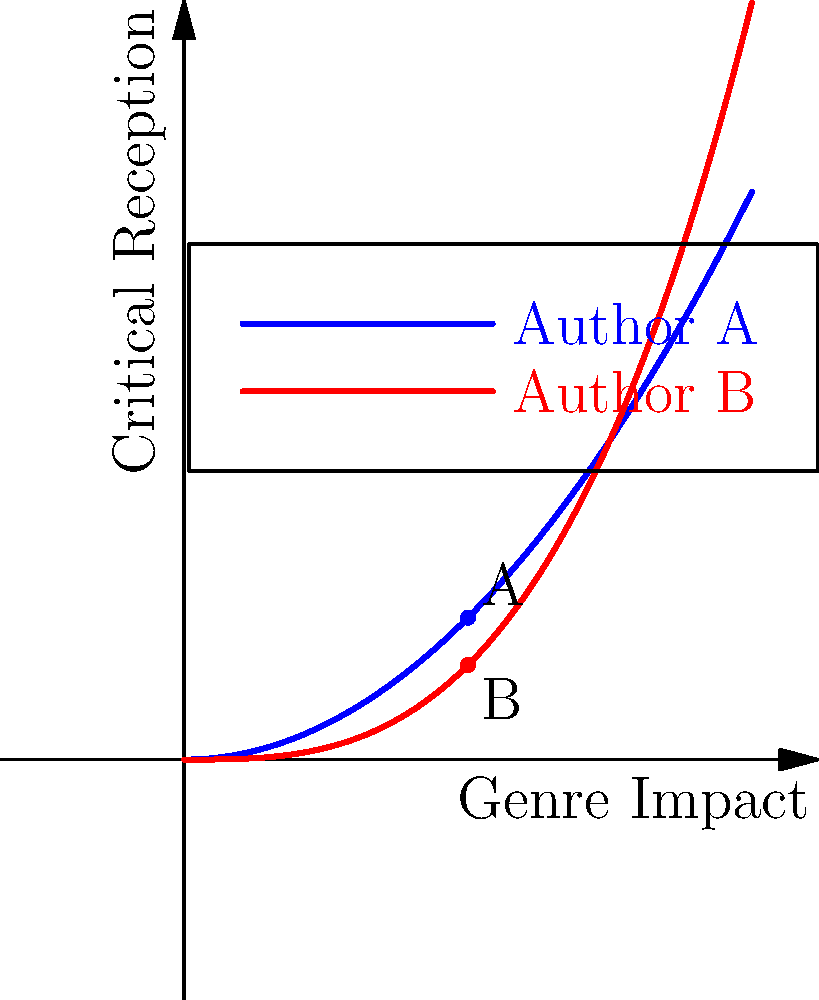Analyze the vector field representing the impact of two authors across different genres. At the point where both authors have equal genre impact (x-axis), which author demonstrates a more significant influence on critical reception (y-axis), and by what factor? To solve this problem, we need to follow these steps:

1. Identify the functions representing each author's impact:
   Author A: $f(x) = 0.5x^2$
   Author B: $g(x) = \frac{x^3}{3}$

2. Find the point where both authors have equal genre impact:
   This occurs at x = 1 on the x-axis.

3. Calculate the critical reception (y-value) for each author at x = 1:
   Author A: $f(1) = 0.5(1)^2 = 0.5$
   Author B: $g(1) = \frac{(1)^3}{3} = \frac{1}{3}$

4. Compare the critical reception values:
   Author A's reception: 0.5
   Author B's reception: $\frac{1}{3}$

5. Calculate the factor of difference:
   $\frac{0.5}{\frac{1}{3}} = \frac{3}{2} = 1.5$

Therefore, at the point of equal genre impact, Author A demonstrates a more significant influence on critical reception by a factor of 1.5 compared to Author B.
Answer: Author A, by a factor of 1.5 